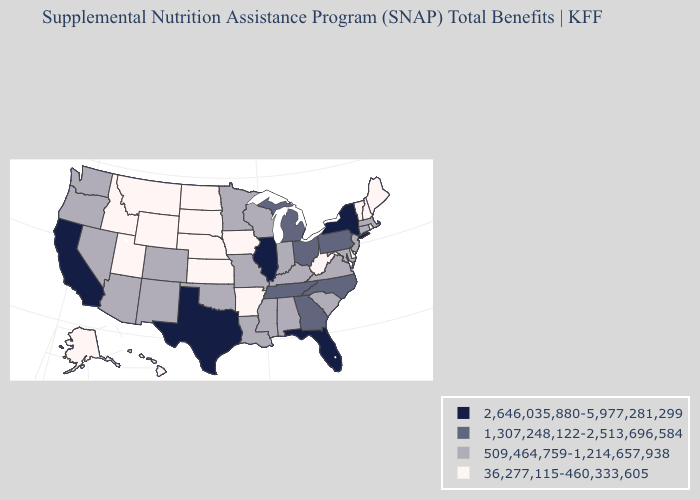What is the lowest value in the West?
Quick response, please. 36,277,115-460,333,605. What is the value of Michigan?
Concise answer only. 1,307,248,122-2,513,696,584. What is the value of South Dakota?
Quick response, please. 36,277,115-460,333,605. What is the highest value in states that border Massachusetts?
Keep it brief. 2,646,035,880-5,977,281,299. What is the lowest value in the Northeast?
Short answer required. 36,277,115-460,333,605. What is the highest value in the Northeast ?
Give a very brief answer. 2,646,035,880-5,977,281,299. Does the first symbol in the legend represent the smallest category?
Keep it brief. No. Does Maine have the lowest value in the USA?
Be succinct. Yes. Among the states that border Illinois , does Iowa have the highest value?
Quick response, please. No. Name the states that have a value in the range 2,646,035,880-5,977,281,299?
Write a very short answer. California, Florida, Illinois, New York, Texas. Name the states that have a value in the range 36,277,115-460,333,605?
Be succinct. Alaska, Arkansas, Delaware, Hawaii, Idaho, Iowa, Kansas, Maine, Montana, Nebraska, New Hampshire, North Dakota, Rhode Island, South Dakota, Utah, Vermont, West Virginia, Wyoming. What is the highest value in states that border Wyoming?
Give a very brief answer. 509,464,759-1,214,657,938. Which states have the highest value in the USA?
Give a very brief answer. California, Florida, Illinois, New York, Texas. Does Georgia have the lowest value in the South?
Give a very brief answer. No. 